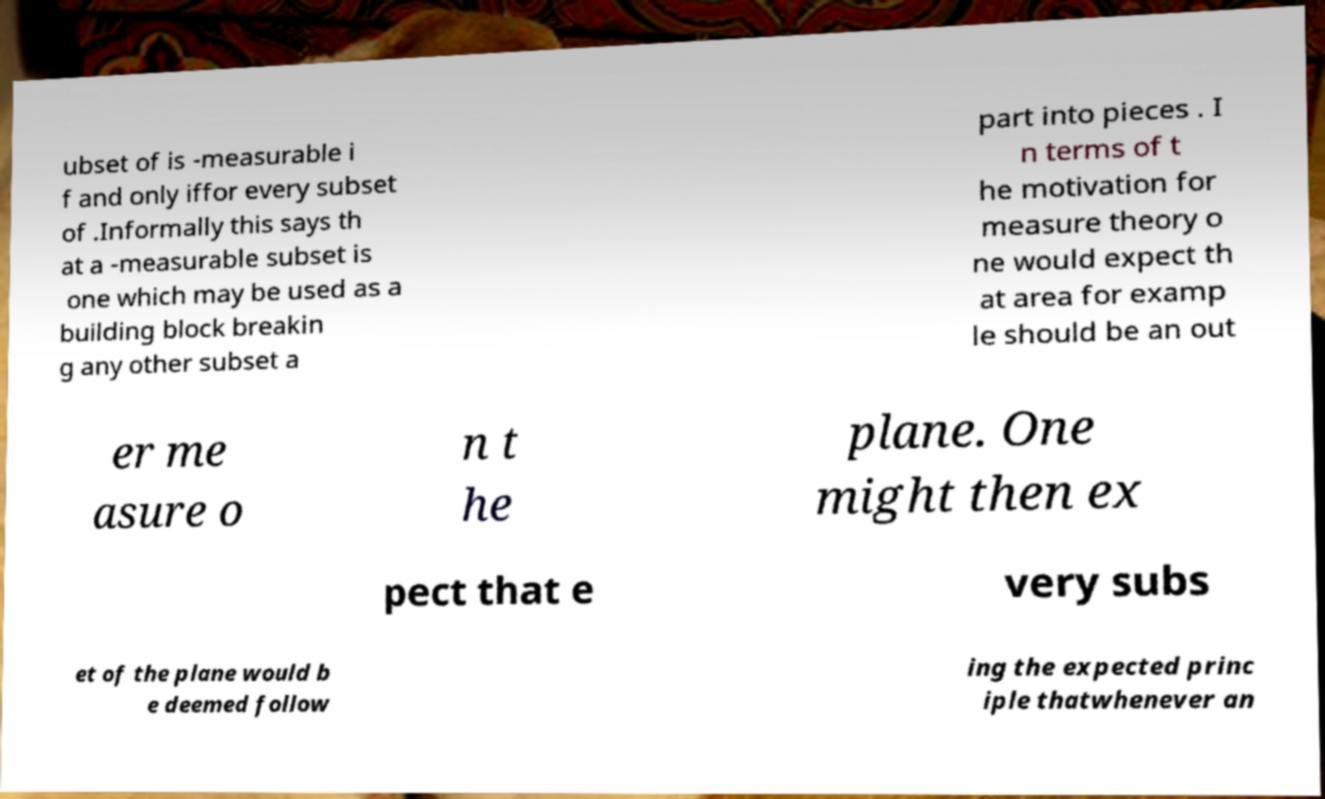Please read and relay the text visible in this image. What does it say? ubset of is -measurable i f and only iffor every subset of .Informally this says th at a -measurable subset is one which may be used as a building block breakin g any other subset a part into pieces . I n terms of t he motivation for measure theory o ne would expect th at area for examp le should be an out er me asure o n t he plane. One might then ex pect that e very subs et of the plane would b e deemed follow ing the expected princ iple thatwhenever an 